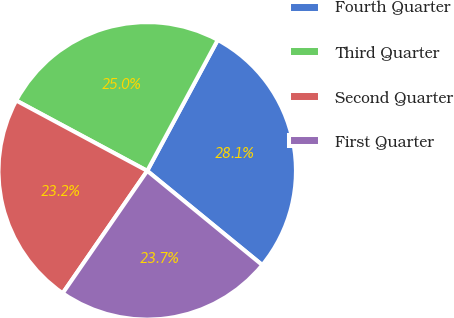<chart> <loc_0><loc_0><loc_500><loc_500><pie_chart><fcel>Fourth Quarter<fcel>Third Quarter<fcel>Second Quarter<fcel>First Quarter<nl><fcel>28.05%<fcel>25.02%<fcel>23.22%<fcel>23.7%<nl></chart> 